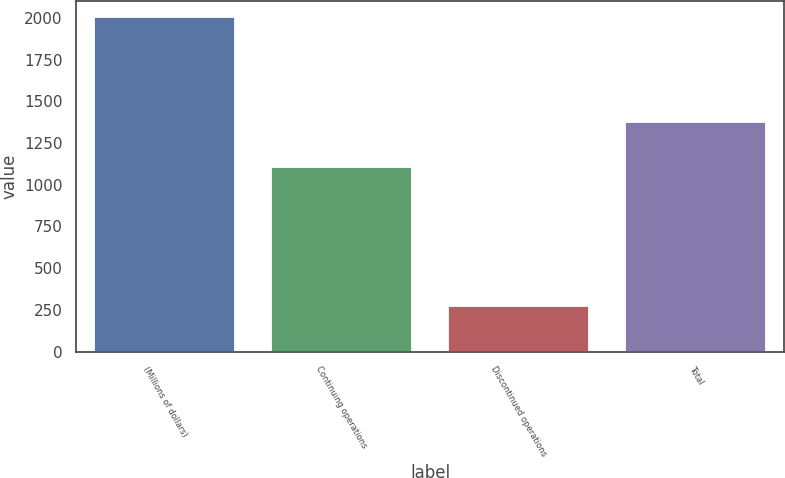Convert chart. <chart><loc_0><loc_0><loc_500><loc_500><bar_chart><fcel>(Millions of dollars)<fcel>Continuing operations<fcel>Discontinued operations<fcel>Total<nl><fcel>2003<fcel>1107<fcel>271<fcel>1378<nl></chart> 